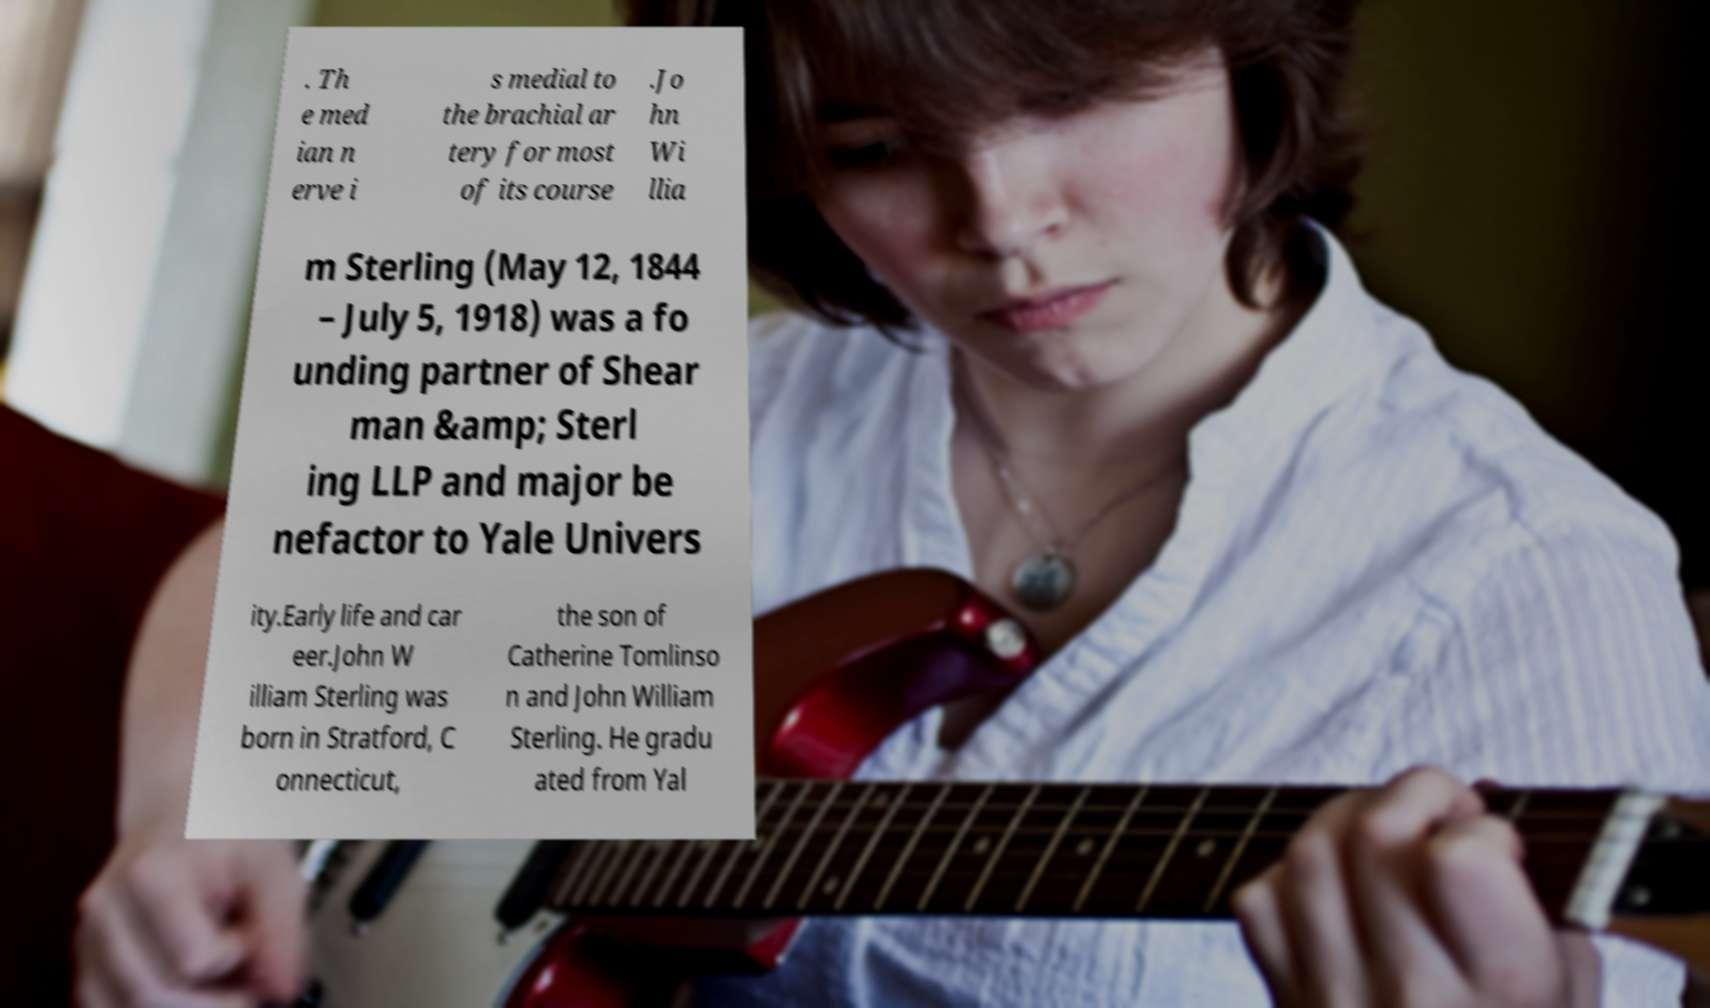What messages or text are displayed in this image? I need them in a readable, typed format. . Th e med ian n erve i s medial to the brachial ar tery for most of its course .Jo hn Wi llia m Sterling (May 12, 1844 – July 5, 1918) was a fo unding partner of Shear man &amp; Sterl ing LLP and major be nefactor to Yale Univers ity.Early life and car eer.John W illiam Sterling was born in Stratford, C onnecticut, the son of Catherine Tomlinso n and John William Sterling. He gradu ated from Yal 